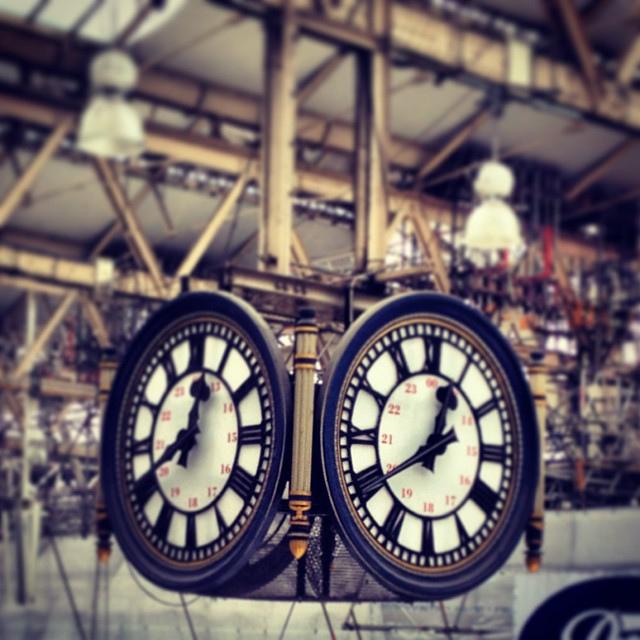Is this a grandfather clock?
Be succinct. No. Do both clock have identical times?
Be succinct. Yes. How many lights can be seen in this photo?
Short answer required. 2. 